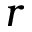<formula> <loc_0><loc_0><loc_500><loc_500>r</formula> 